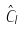<formula> <loc_0><loc_0><loc_500><loc_500>\hat { C } _ { I }</formula> 